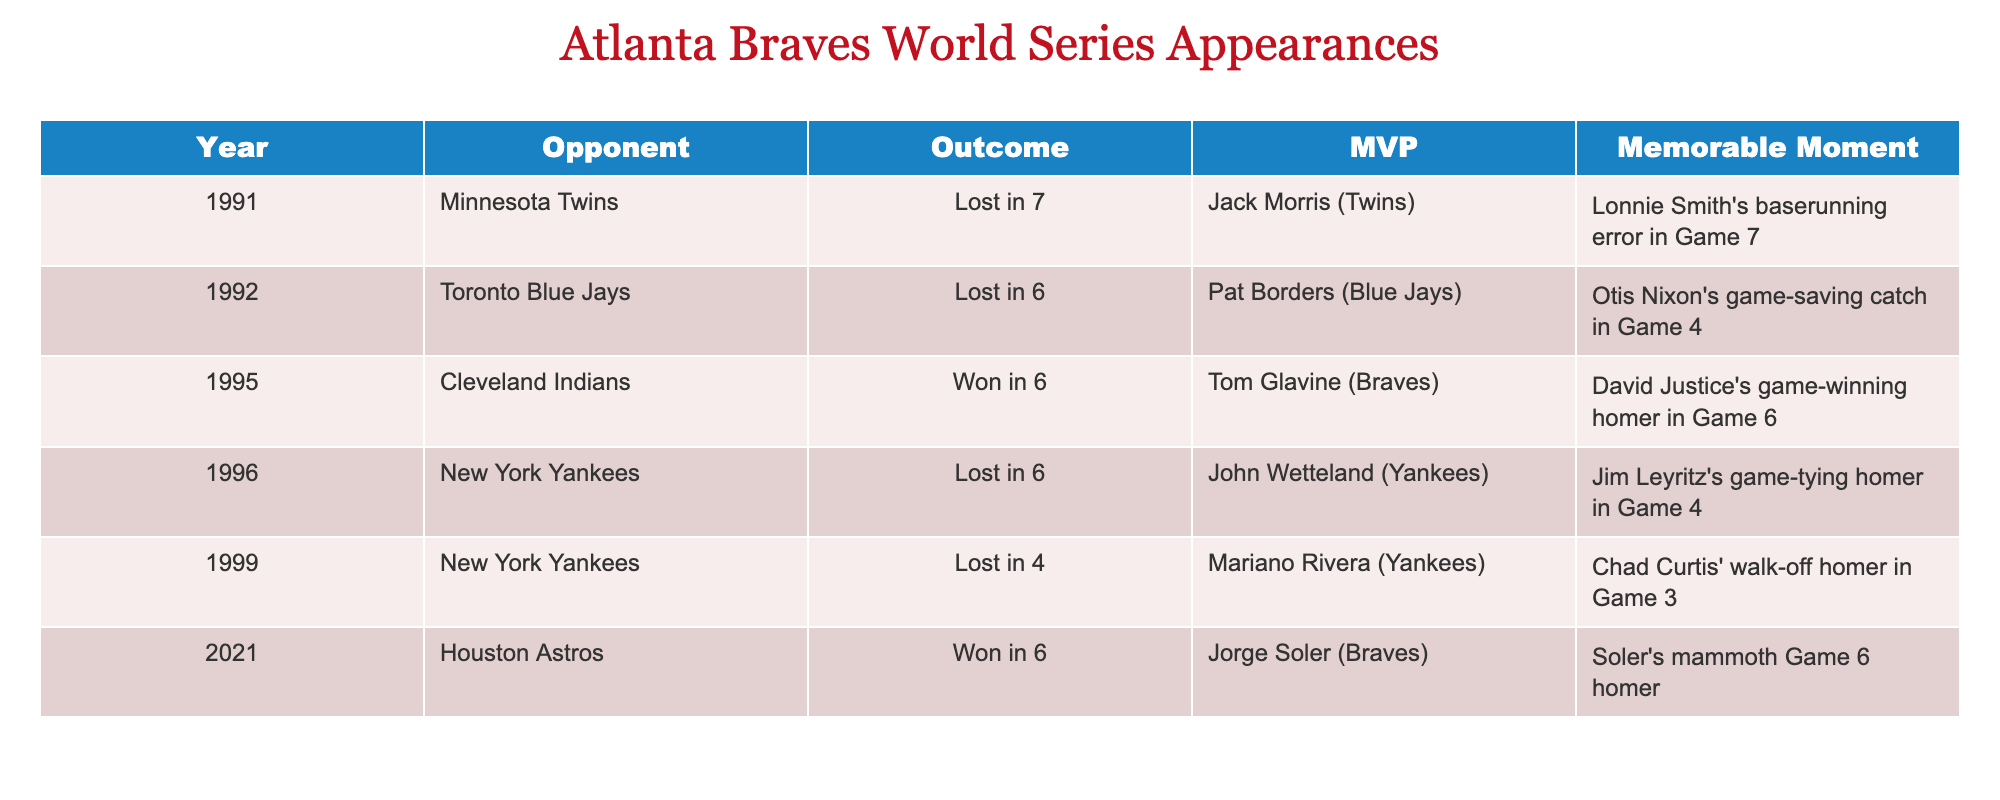What year did the Braves last win the World Series? The table shows that the Braves won the World Series in 2021. The “Outcome” column for that year indicates a win.
Answer: 2021 Who was the MVP in the 1995 World Series? The table lists Tom Glavine as the MVP for the 1995 World Series in the "MVP" column.
Answer: Tom Glavine How many World Series appearances did the Braves lose? By examining the "Outcome" column, we see that the Braves lost the World Series in 1991, 1992, 1996, and 1999, which totals four losses.
Answer: 4 Which opponent did the Braves face in their first World Series appearance since 1966? The first listed year in the table is 1991, where the Braves faced the Minnesota Twins. This indicates that the Braves' first appearance was against them.
Answer: Minnesota Twins What is the memorable moment from the 1991 World Series? According to the table, the memorable moment in the 1991 World Series was Lonnie Smith's baserunning error in Game 7.
Answer: Lonnie Smith's baserunning error in Game 7 How many years did it take for the Braves to win after their last loss before 2021? The Braves lost the World Series in 1999 and won it in 2021. The number of years between these events is 2021 - 1999 = 22.
Answer: 22 Did the Braves face the New York Yankees more than once? The table shows that the Braves faced the New York Yankees in 1996 and 1999, indicating that they faced them twice.
Answer: Yes Which World Series had a memorable moment involving a game-saving catch? In the table, the 1992 World Series has the memorable moment of Otis Nixon's game-saving catch in Game 4.
Answer: 1992 What is the overall record of wins to losses in World Series based on the data? The Braves won in 1995 and 2021, resulting in 2 wins. They lost in 1991, 1992, 1996, and 1999, totaling 4 losses. Therefore, the record shows 2 wins and 4 losses.
Answer: 2 wins, 4 losses Which two teams did the Braves lose to that resulted in a six-game series? The table indicates the Braves lost in six games to both the Minnesota Twins in 1991 and the Toronto Blue Jays in 1992.
Answer: Minnesota Twins, Toronto Blue Jays 